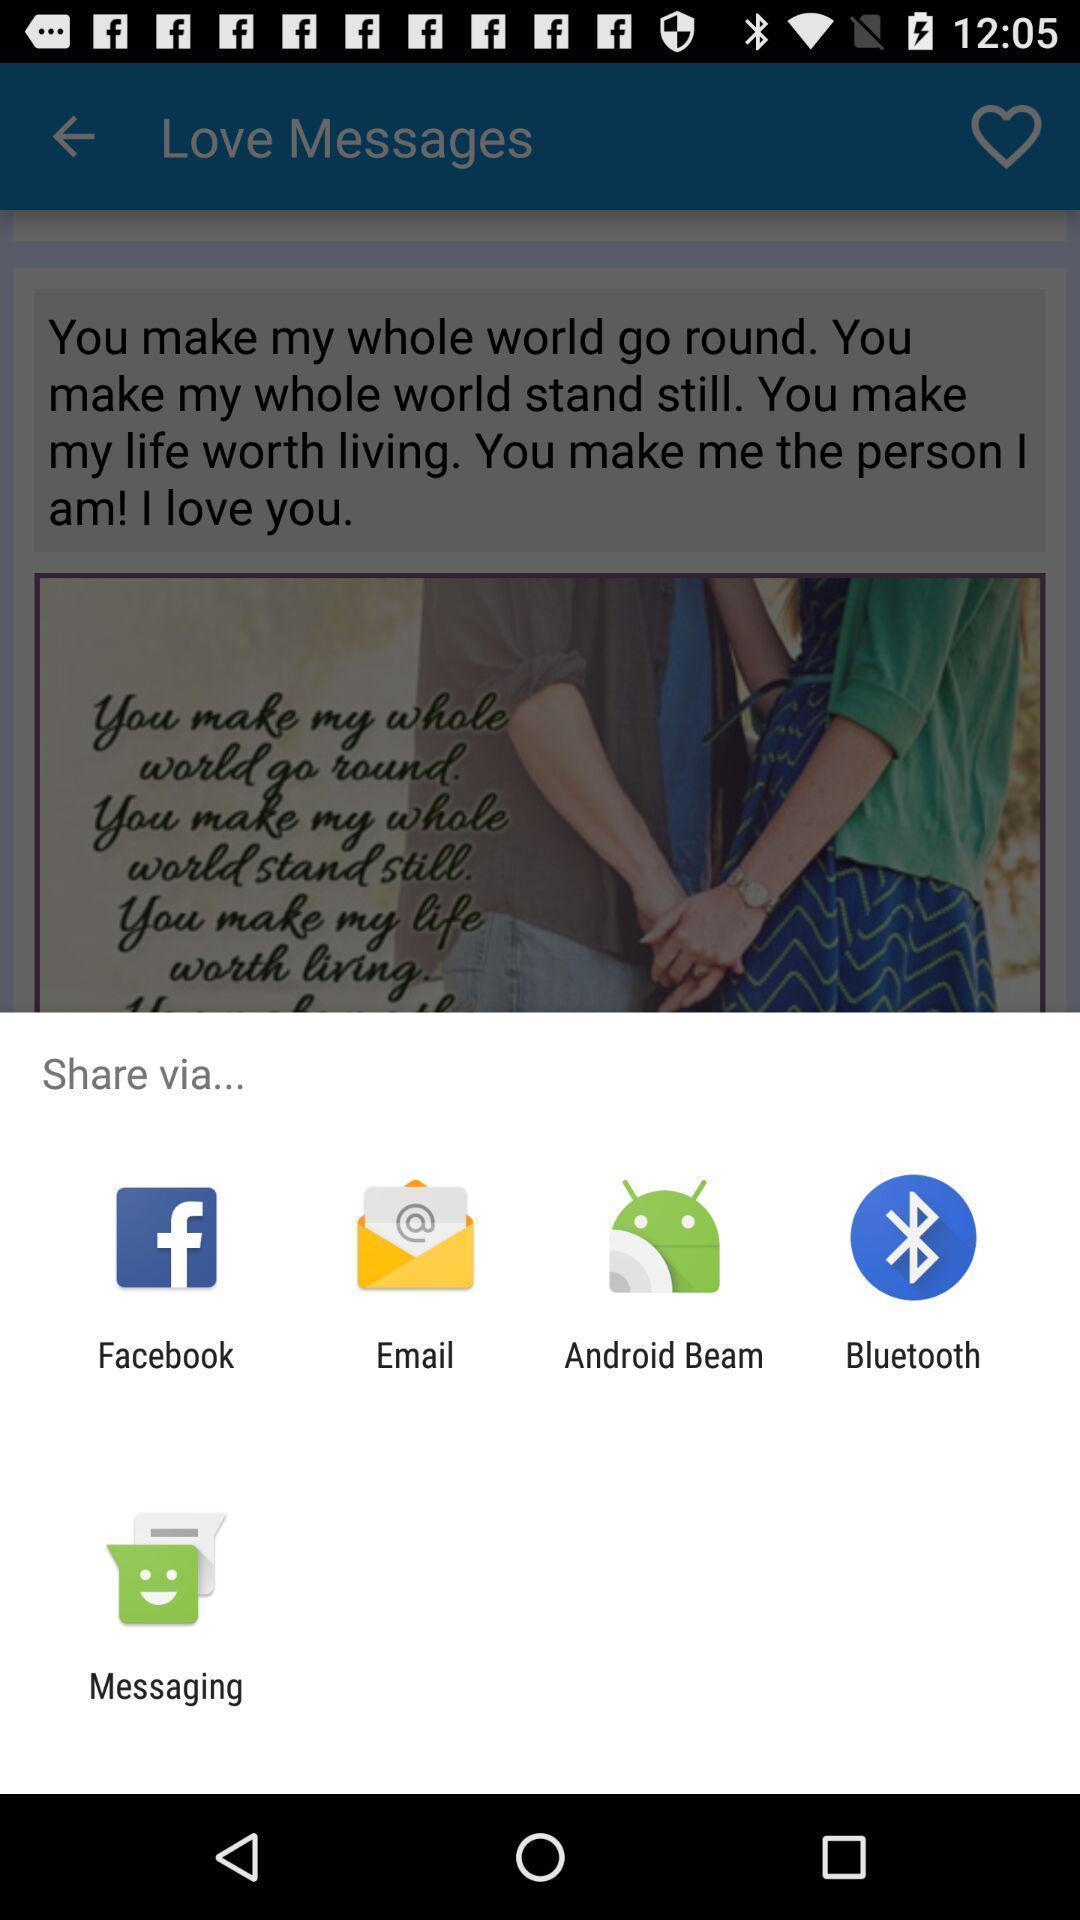Describe this image in words. Popup showing different apps to share. 